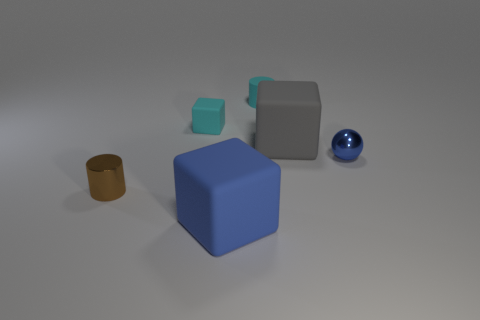Add 1 gray objects. How many objects exist? 7 Subtract all balls. How many objects are left? 5 Subtract 0 cyan spheres. How many objects are left? 6 Subtract all gray blocks. Subtract all tiny matte objects. How many objects are left? 3 Add 3 big blue matte blocks. How many big blue matte blocks are left? 4 Add 4 large yellow cubes. How many large yellow cubes exist? 4 